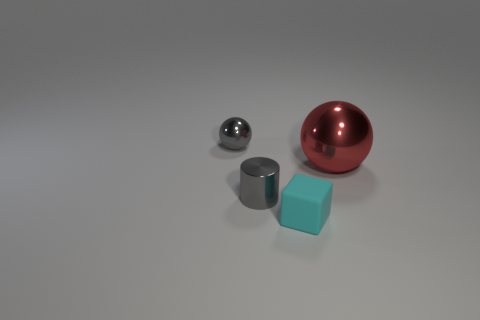Are there any other things that are made of the same material as the tiny gray sphere?
Offer a terse response. Yes. Do the cube and the ball that is to the left of the red shiny thing have the same material?
Offer a terse response. No. Are there fewer small objects to the left of the cyan cube than small shiny balls that are behind the gray cylinder?
Offer a terse response. No. What is the material of the sphere in front of the small ball?
Provide a short and direct response. Metal. The shiny object that is both on the right side of the small sphere and left of the large red metal object is what color?
Your response must be concise. Gray. What number of other objects are the same color as the small cylinder?
Offer a very short reply. 1. What color is the matte thing in front of the red object?
Offer a terse response. Cyan. Are there any brown shiny cubes that have the same size as the cyan matte block?
Give a very brief answer. No. There is a gray sphere that is the same size as the cyan object; what is it made of?
Make the answer very short. Metal. What number of objects are gray shiny objects that are in front of the tiny gray metallic sphere or tiny gray metallic cylinders that are in front of the red shiny thing?
Provide a succinct answer. 1. 